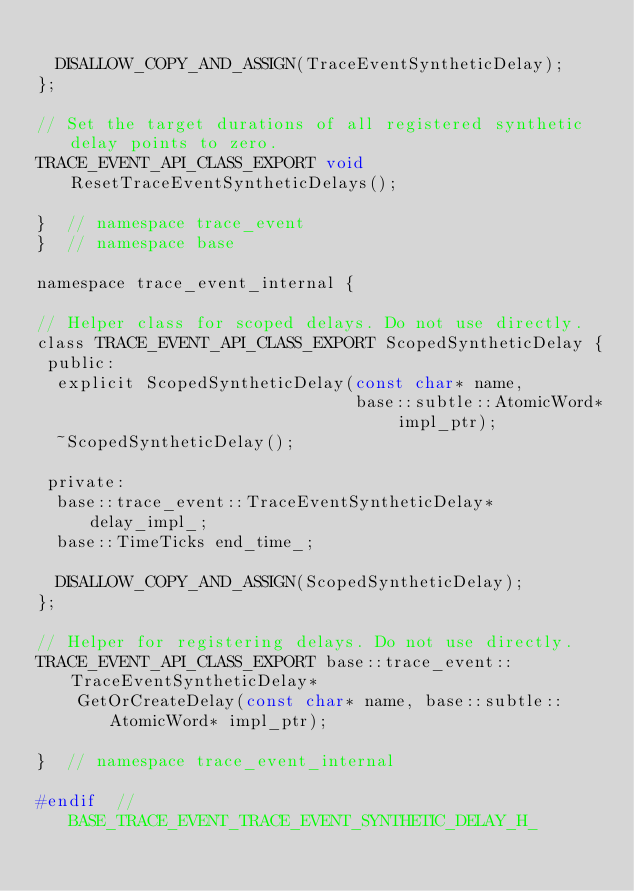<code> <loc_0><loc_0><loc_500><loc_500><_C_>
  DISALLOW_COPY_AND_ASSIGN(TraceEventSyntheticDelay);
};

// Set the target durations of all registered synthetic delay points to zero.
TRACE_EVENT_API_CLASS_EXPORT void ResetTraceEventSyntheticDelays();

}  // namespace trace_event
}  // namespace base

namespace trace_event_internal {

// Helper class for scoped delays. Do not use directly.
class TRACE_EVENT_API_CLASS_EXPORT ScopedSyntheticDelay {
 public:
  explicit ScopedSyntheticDelay(const char* name,
                                base::subtle::AtomicWord* impl_ptr);
  ~ScopedSyntheticDelay();

 private:
  base::trace_event::TraceEventSyntheticDelay* delay_impl_;
  base::TimeTicks end_time_;

  DISALLOW_COPY_AND_ASSIGN(ScopedSyntheticDelay);
};

// Helper for registering delays. Do not use directly.
TRACE_EVENT_API_CLASS_EXPORT base::trace_event::TraceEventSyntheticDelay*
    GetOrCreateDelay(const char* name, base::subtle::AtomicWord* impl_ptr);

}  // namespace trace_event_internal

#endif  // BASE_TRACE_EVENT_TRACE_EVENT_SYNTHETIC_DELAY_H_
</code> 